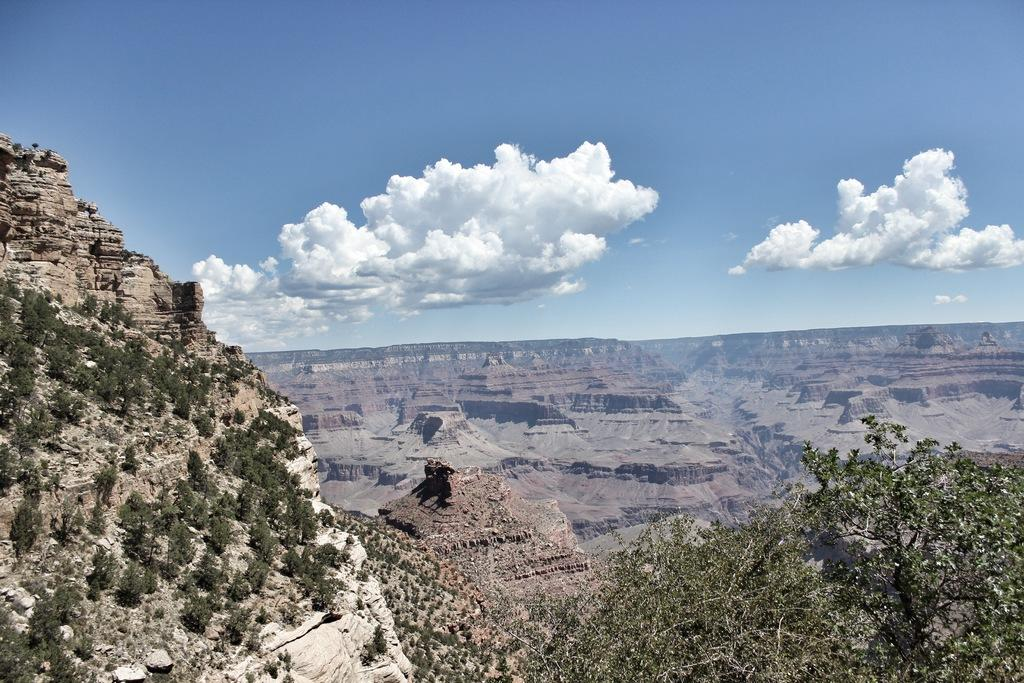What type of natural landscape is depicted in the image? The image features mountains. What other natural elements can be seen in the image? There are plants and trees in the image. What is visible in the sky in the image? There are clouds in the sky in the image. What type of art is displayed on the stage in the image? There is no stage or art present in the image; it features mountains, plants, trees, and clouds. 